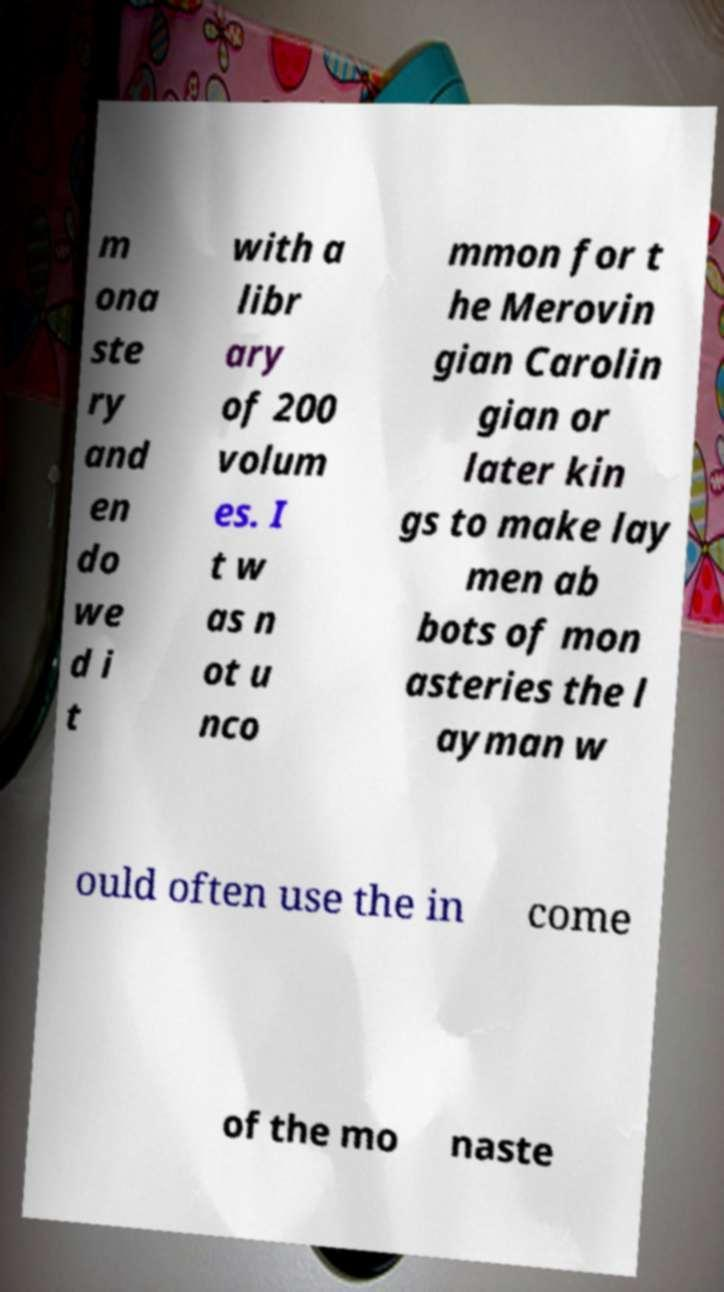Could you assist in decoding the text presented in this image and type it out clearly? m ona ste ry and en do we d i t with a libr ary of 200 volum es. I t w as n ot u nco mmon for t he Merovin gian Carolin gian or later kin gs to make lay men ab bots of mon asteries the l ayman w ould often use the in come of the mo naste 